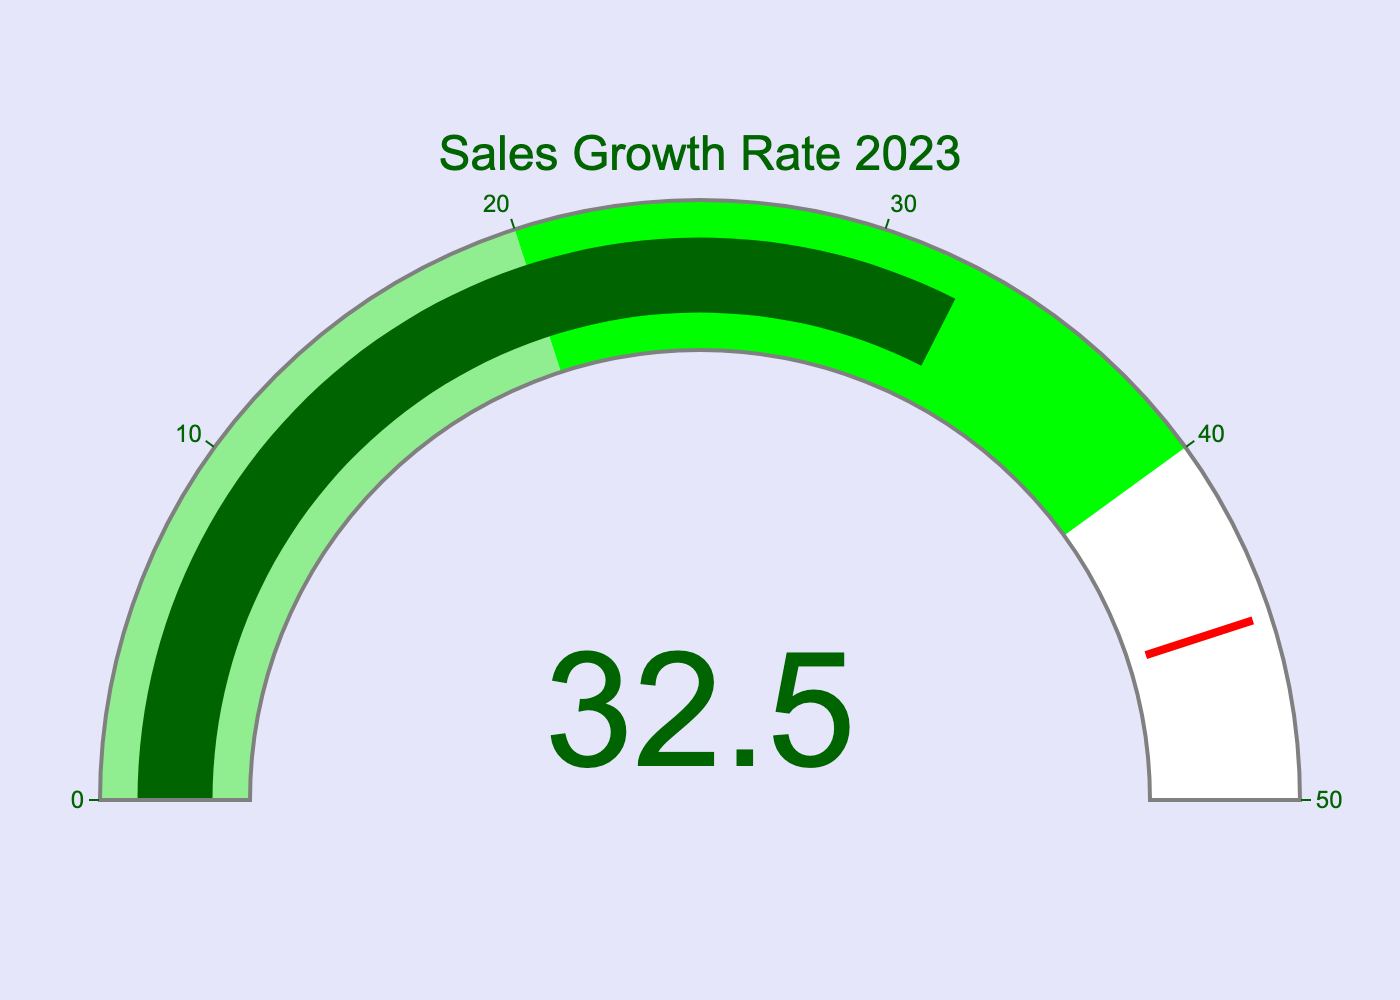What is the title of the gauge chart? The title of the gauge chart is typically displayed at the top of the gauge. In this chart, it reads "Sales Growth Rate 2023".
Answer: Sales Growth Rate 2023 What is the value shown on the gauge? The value shown on the gauge is displayed in the middle of the gauge. In this chart, the value is 32.5.
Answer: 32.5 What color is the bar indicating the sales growth rate? The bar color represents the actual value on the gauge. In this chart, the bar is colored dark green.
Answer: Dark green What is the range of the gauge? The range of the gauge is shown by the ticks on the outer ring. In this chart, the range is from 0 to 50.
Answer: 0 to 50 Which color represents higher sales growth: lightgreen or lime? The gauge depicts a segmented range with different colors. Light green represents the range from 0 to 20, and lime represents the range from 20 to 40, so lime represents higher sales growth.
Answer: Lime Is the sales growth rate closer to the lower end or the higher end of the gauge range? The gauge range is from 0 to 50, and the sales growth rate shown is 32.5, which is closer to the middle but towards the higher end since 32.5 is greater than the midpoint of 25.
Answer: Higher end What is the significance of the red line on the gauge? The red line represents a threshold value. In this chart, it is set at 45, indicating a significant benchmark or warning level for the sales growth rate.
Answer: Threshold value By how much does the current sales growth rate exceed the upper limit of the light green range? The light green range ends at 20, and the current sales growth rate is 32.5. The amount by which the sales growth rate exceeds the upper limit of the light green range is 32.5 - 20 = 12.5.
Answer: 12.5 What does the threshold value indicate, and how close is the current sales growth to it? The threshold value, indicated by the red line, is set at 45. The current sales growth rate is 32.5, which is 45 - 32.5 = 12.5 units away from reaching the threshold.
Answer: 12.5 units away What is the difference between the current sales growth rate and the midpoint of the gauge range? The midpoint of the gauge range (0 to 50) is 25. The difference between the current sales growth rate (32.5) and the midpoint is 32.5 - 25 = 7.5.
Answer: 7.5 